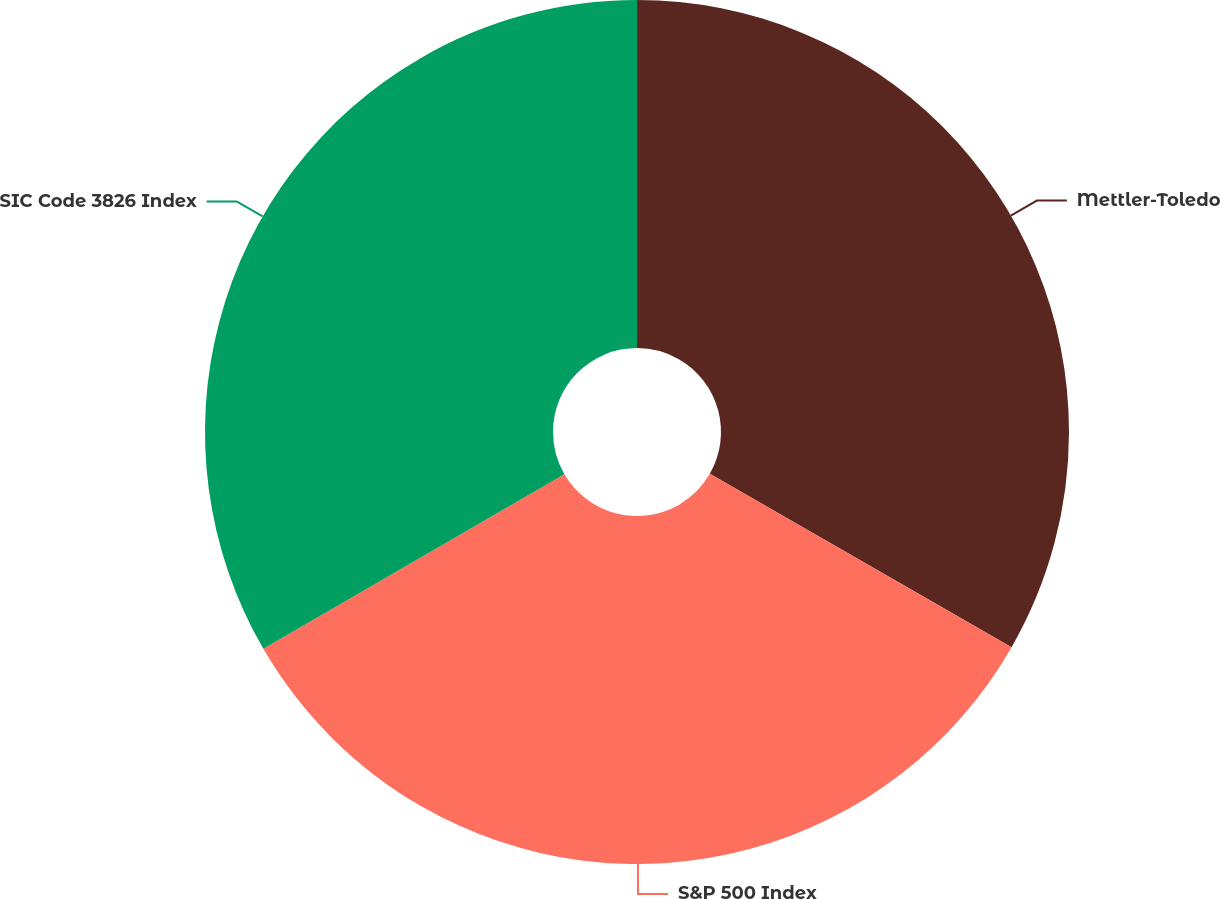Convert chart. <chart><loc_0><loc_0><loc_500><loc_500><pie_chart><fcel>Mettler-Toledo<fcel>S&P 500 Index<fcel>SIC Code 3826 Index<nl><fcel>33.3%<fcel>33.33%<fcel>33.37%<nl></chart> 